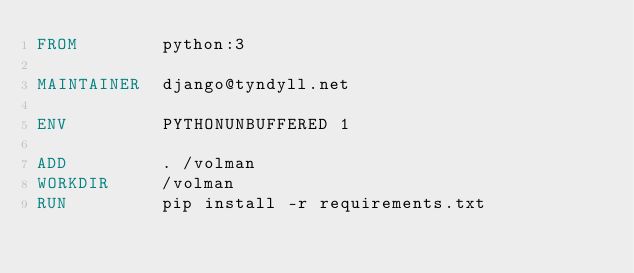<code> <loc_0><loc_0><loc_500><loc_500><_Dockerfile_>FROM        python:3

MAINTAINER  django@tyndyll.net

ENV         PYTHONUNBUFFERED 1

ADD         . /volman
WORKDIR     /volman
RUN         pip install -r requirements.txt


</code> 